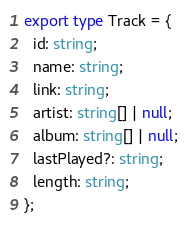<code> <loc_0><loc_0><loc_500><loc_500><_TypeScript_>export type Track = {
  id: string;
  name: string;
  link: string;
  artist: string[] | null;
  album: string[] | null;
  lastPlayed?: string;
  length: string;
};
</code> 